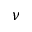<formula> <loc_0><loc_0><loc_500><loc_500>\nu</formula> 